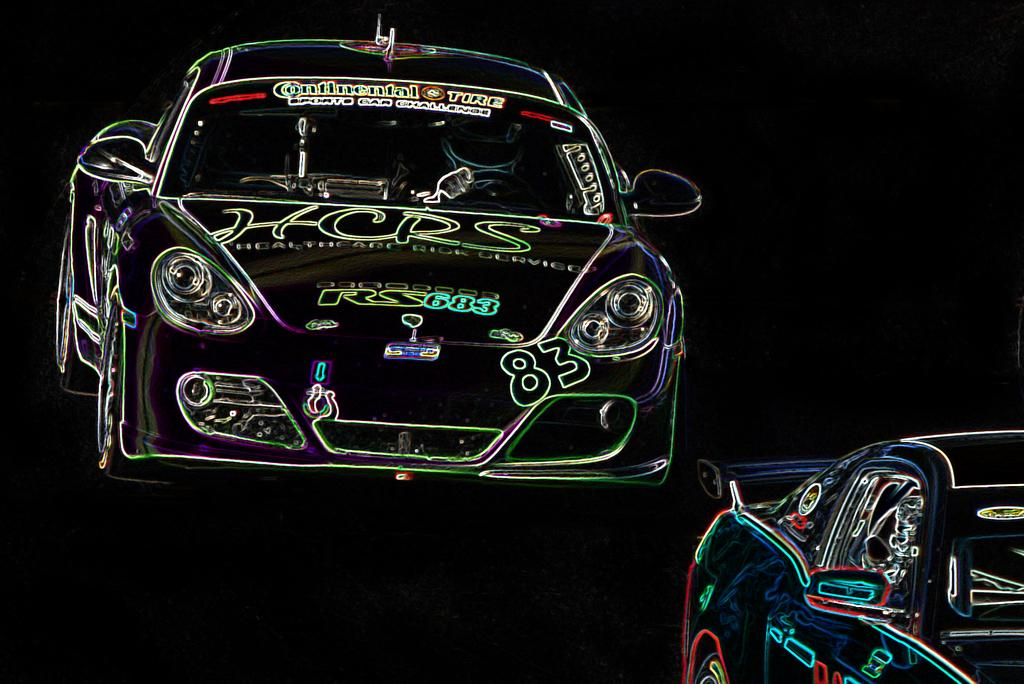What is the main subject of the image? The main subject of the image is an animation of two cars. Can you describe the animation in more detail? Unfortunately, the provided facts do not offer any additional details about the animation. What type of organization is depicted in the image? There is no organization depicted in the image; it features an animation of two cars. What kind of furniture can be seen in the image? There is no furniture present in the image; it features an animation of two cars. 